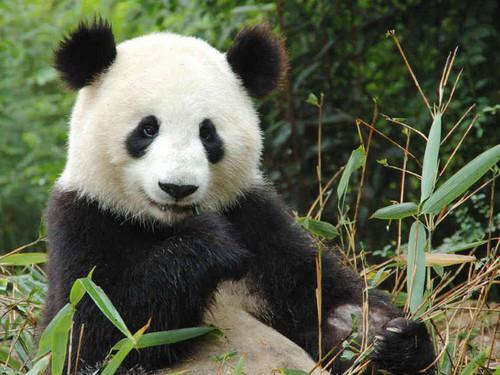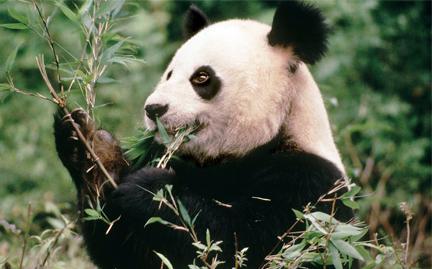The first image is the image on the left, the second image is the image on the right. Evaluate the accuracy of this statement regarding the images: "Only one image shows a panda munching on some type of foliage.". Is it true? Answer yes or no. No. 